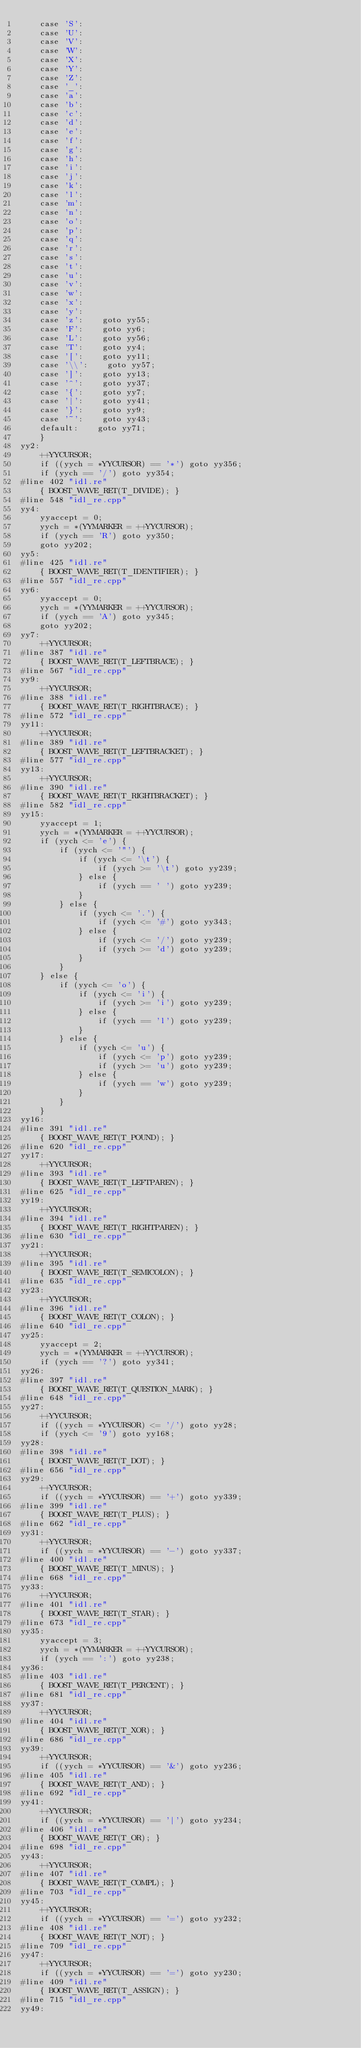Convert code to text. <code><loc_0><loc_0><loc_500><loc_500><_C++_>    case 'S':
    case 'U':
    case 'V':
    case 'W':
    case 'X':
    case 'Y':
    case 'Z':
    case '_':
    case 'a':
    case 'b':
    case 'c':
    case 'd':
    case 'e':
    case 'f':
    case 'g':
    case 'h':
    case 'i':
    case 'j':
    case 'k':
    case 'l':
    case 'm':
    case 'n':
    case 'o':
    case 'p':
    case 'q':
    case 'r':
    case 's':
    case 't':
    case 'u':
    case 'v':
    case 'w':
    case 'x':
    case 'y':
    case 'z':    goto yy55;
    case 'F':    goto yy6;
    case 'L':    goto yy56;
    case 'T':    goto yy4;
    case '[':    goto yy11;
    case '\\':    goto yy57;
    case ']':    goto yy13;
    case '^':    goto yy37;
    case '{':    goto yy7;
    case '|':    goto yy41;
    case '}':    goto yy9;
    case '~':    goto yy43;
    default:    goto yy71;
    }
yy2:
    ++YYCURSOR;
    if ((yych = *YYCURSOR) == '*') goto yy356;
    if (yych == '/') goto yy354;
#line 402 "idl.re"
    { BOOST_WAVE_RET(T_DIVIDE); }
#line 548 "idl_re.cpp"
yy4:
    yyaccept = 0;
    yych = *(YYMARKER = ++YYCURSOR);
    if (yych == 'R') goto yy350;
    goto yy202;
yy5:
#line 425 "idl.re"
    { BOOST_WAVE_RET(T_IDENTIFIER); }
#line 557 "idl_re.cpp"
yy6:
    yyaccept = 0;
    yych = *(YYMARKER = ++YYCURSOR);
    if (yych == 'A') goto yy345;
    goto yy202;
yy7:
    ++YYCURSOR;
#line 387 "idl.re"
    { BOOST_WAVE_RET(T_LEFTBRACE); }
#line 567 "idl_re.cpp"
yy9:
    ++YYCURSOR;
#line 388 "idl.re"
    { BOOST_WAVE_RET(T_RIGHTBRACE); }
#line 572 "idl_re.cpp"
yy11:
    ++YYCURSOR;
#line 389 "idl.re"
    { BOOST_WAVE_RET(T_LEFTBRACKET); }
#line 577 "idl_re.cpp"
yy13:
    ++YYCURSOR;
#line 390 "idl.re"
    { BOOST_WAVE_RET(T_RIGHTBRACKET); }
#line 582 "idl_re.cpp"
yy15:
    yyaccept = 1;
    yych = *(YYMARKER = ++YYCURSOR);
    if (yych <= 'e') {
        if (yych <= '"') {
            if (yych <= '\t') {
                if (yych >= '\t') goto yy239;
            } else {
                if (yych == ' ') goto yy239;
            }
        } else {
            if (yych <= '.') {
                if (yych <= '#') goto yy343;
            } else {
                if (yych <= '/') goto yy239;
                if (yych >= 'd') goto yy239;
            }
        }
    } else {
        if (yych <= 'o') {
            if (yych <= 'i') {
                if (yych >= 'i') goto yy239;
            } else {
                if (yych == 'l') goto yy239;
            }
        } else {
            if (yych <= 'u') {
                if (yych <= 'p') goto yy239;
                if (yych >= 'u') goto yy239;
            } else {
                if (yych == 'w') goto yy239;
            }
        }
    }
yy16:
#line 391 "idl.re"
    { BOOST_WAVE_RET(T_POUND); }
#line 620 "idl_re.cpp"
yy17:
    ++YYCURSOR;
#line 393 "idl.re"
    { BOOST_WAVE_RET(T_LEFTPAREN); }
#line 625 "idl_re.cpp"
yy19:
    ++YYCURSOR;
#line 394 "idl.re"
    { BOOST_WAVE_RET(T_RIGHTPAREN); }
#line 630 "idl_re.cpp"
yy21:
    ++YYCURSOR;
#line 395 "idl.re"
    { BOOST_WAVE_RET(T_SEMICOLON); }
#line 635 "idl_re.cpp"
yy23:
    ++YYCURSOR;
#line 396 "idl.re"
    { BOOST_WAVE_RET(T_COLON); }
#line 640 "idl_re.cpp"
yy25:
    yyaccept = 2;
    yych = *(YYMARKER = ++YYCURSOR);
    if (yych == '?') goto yy341;
yy26:
#line 397 "idl.re"
    { BOOST_WAVE_RET(T_QUESTION_MARK); }
#line 648 "idl_re.cpp"
yy27:
    ++YYCURSOR;
    if ((yych = *YYCURSOR) <= '/') goto yy28;
    if (yych <= '9') goto yy168;
yy28:
#line 398 "idl.re"
    { BOOST_WAVE_RET(T_DOT); }
#line 656 "idl_re.cpp"
yy29:
    ++YYCURSOR;
    if ((yych = *YYCURSOR) == '+') goto yy339;
#line 399 "idl.re"
    { BOOST_WAVE_RET(T_PLUS); }
#line 662 "idl_re.cpp"
yy31:
    ++YYCURSOR;
    if ((yych = *YYCURSOR) == '-') goto yy337;
#line 400 "idl.re"
    { BOOST_WAVE_RET(T_MINUS); }
#line 668 "idl_re.cpp"
yy33:
    ++YYCURSOR;
#line 401 "idl.re"
    { BOOST_WAVE_RET(T_STAR); }
#line 673 "idl_re.cpp"
yy35:
    yyaccept = 3;
    yych = *(YYMARKER = ++YYCURSOR);
    if (yych == ':') goto yy238;
yy36:
#line 403 "idl.re"
    { BOOST_WAVE_RET(T_PERCENT); }
#line 681 "idl_re.cpp"
yy37:
    ++YYCURSOR;
#line 404 "idl.re"
    { BOOST_WAVE_RET(T_XOR); }
#line 686 "idl_re.cpp"
yy39:
    ++YYCURSOR;
    if ((yych = *YYCURSOR) == '&') goto yy236;
#line 405 "idl.re"
    { BOOST_WAVE_RET(T_AND); }
#line 692 "idl_re.cpp"
yy41:
    ++YYCURSOR;
    if ((yych = *YYCURSOR) == '|') goto yy234;
#line 406 "idl.re"
    { BOOST_WAVE_RET(T_OR); }
#line 698 "idl_re.cpp"
yy43:
    ++YYCURSOR;
#line 407 "idl.re"
    { BOOST_WAVE_RET(T_COMPL); }
#line 703 "idl_re.cpp"
yy45:
    ++YYCURSOR;
    if ((yych = *YYCURSOR) == '=') goto yy232;
#line 408 "idl.re"
    { BOOST_WAVE_RET(T_NOT); }
#line 709 "idl_re.cpp"
yy47:
    ++YYCURSOR;
    if ((yych = *YYCURSOR) == '=') goto yy230;
#line 409 "idl.re"
    { BOOST_WAVE_RET(T_ASSIGN); }
#line 715 "idl_re.cpp"
yy49:</code> 